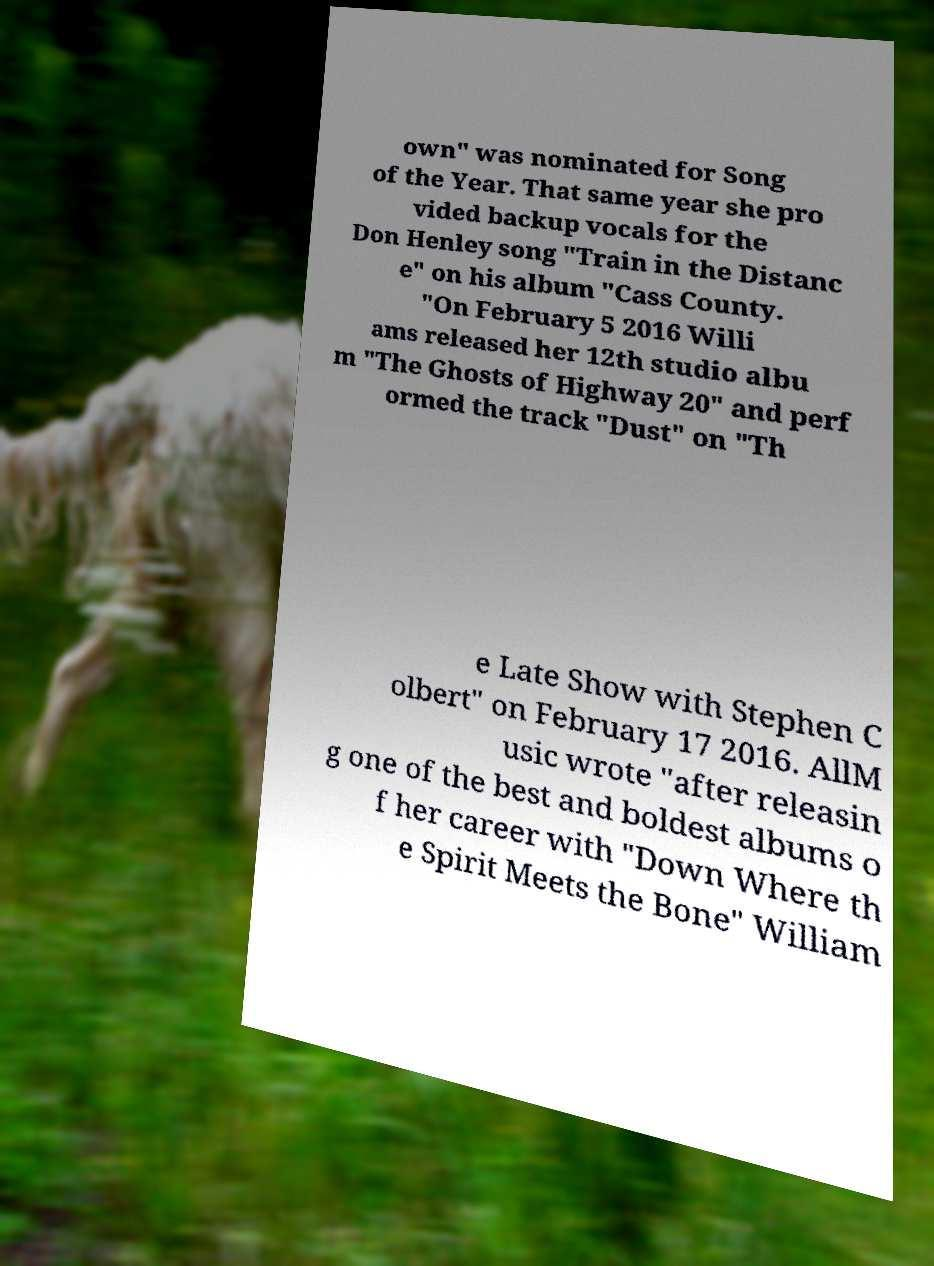Can you accurately transcribe the text from the provided image for me? own" was nominated for Song of the Year. That same year she pro vided backup vocals for the Don Henley song "Train in the Distanc e" on his album "Cass County. "On February 5 2016 Willi ams released her 12th studio albu m "The Ghosts of Highway 20" and perf ormed the track "Dust" on "Th e Late Show with Stephen C olbert" on February 17 2016. AllM usic wrote "after releasin g one of the best and boldest albums o f her career with "Down Where th e Spirit Meets the Bone" William 